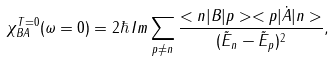Convert formula to latex. <formula><loc_0><loc_0><loc_500><loc_500>\chi ^ { T = 0 } _ { B A } ( \omega = 0 ) = 2 \hbar { \, } I m \sum _ { p \neq n } \frac { < n | B | p > < p | \dot { A } | n > } { ( \tilde { E } _ { n } - \tilde { E } _ { p } ) ^ { 2 } } ,</formula> 